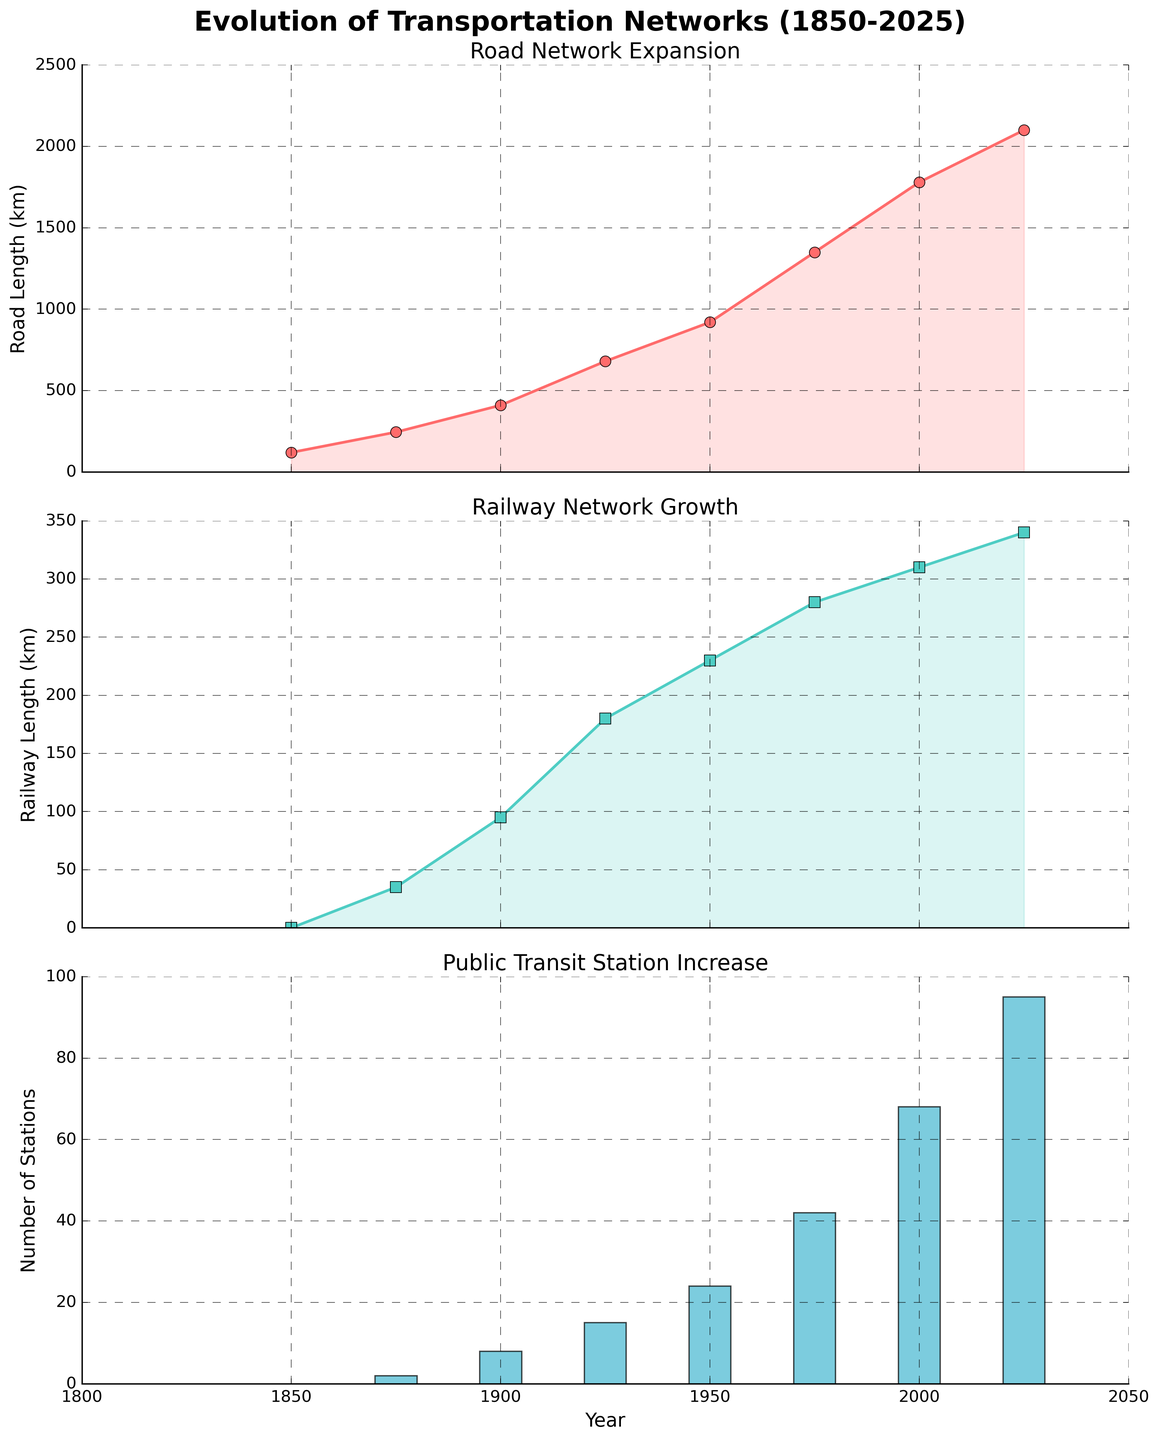What is the title of the plot depicting the evolution of roads? Look at the title above the first subplot to identify the text.
Answer: Road Network Expansion How many public transit stations were there in 1950? Find the bar corresponding to 1950 in the third subplot and read the value.
Answer: 24 What was the length of railways in 1875? Locate the point for 1875 on the second subplot and read the corresponding y-axis value.
Answer: 35 km Which means of transportation had the quickest growth between 1850 and 2000? Examine the slopes of the lines and bars over this period. Roads show a steeper increase compared to railways and public transit stations.
Answer: Roads What is the difference in the number of public transit stations between 1975 and 2025? Find the values for both years in the third subplot, and subtract the earlier value from the later value. 68 - 42 = 26
Answer: 26 During which period did the railway length see the greatest increase? Observe the second subplot to compare the increases between each pair of consecutive points. The increase from 1900 to 1925 is the largest.
Answer: 1900-1925 What is the total length of roads in 2025? Read the value at the far right of the first subplot.
Answer: 2100 km On how many different years is data plotted in the figures? Count the number of data points in any subplot. There are eight points representing different years.
Answer: 8 Which mode of transportation had the smallest increase from 2000 to 2025? Look at the trends from 2000 to 2025 for all three subplots. Railway length increased the least.
Answer: Railways How did the number of public transit stations change between 1925 and 1950? Check the third subplot between 1925 and 1950 and note the increase in y-axis value from 15 to 24.
Answer: Increased from 15 to 24 